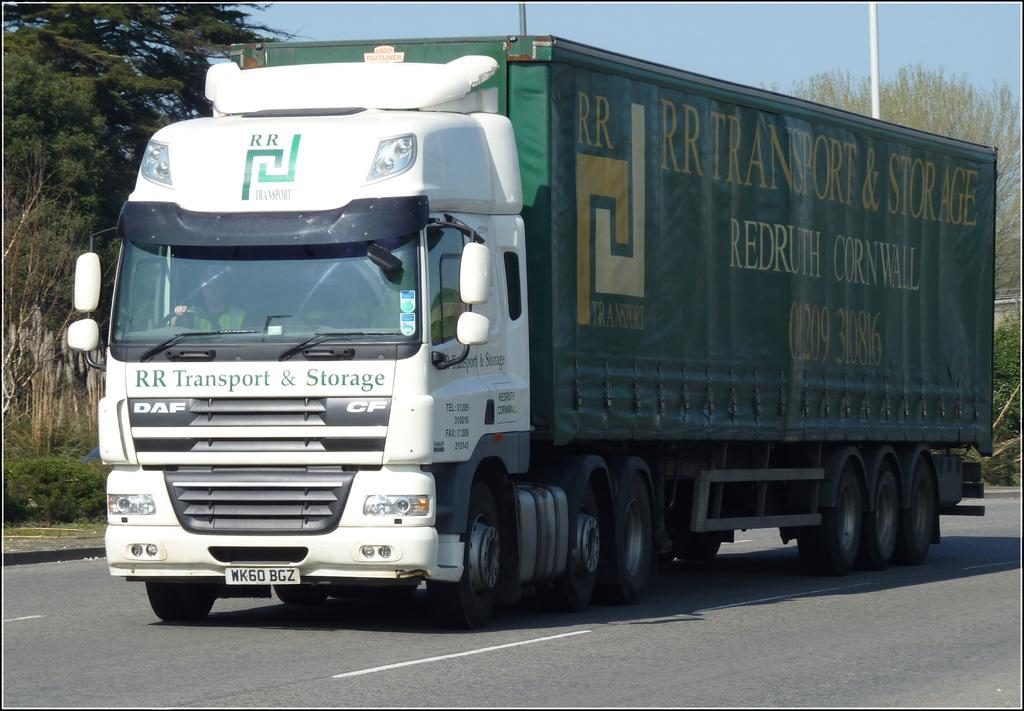What type of vehicle is on the road in the image? There is a truck on the road in the image. Who is inside the truck? There are people seated in the truck. What can be seen in the background of the image? There are poles and trees visible in the background of the image. Where is the toothbrush located in the image? There is no toothbrush present in the image. What type of hole can be seen in the truck in the image? There is no hole visible in the truck in the image. 